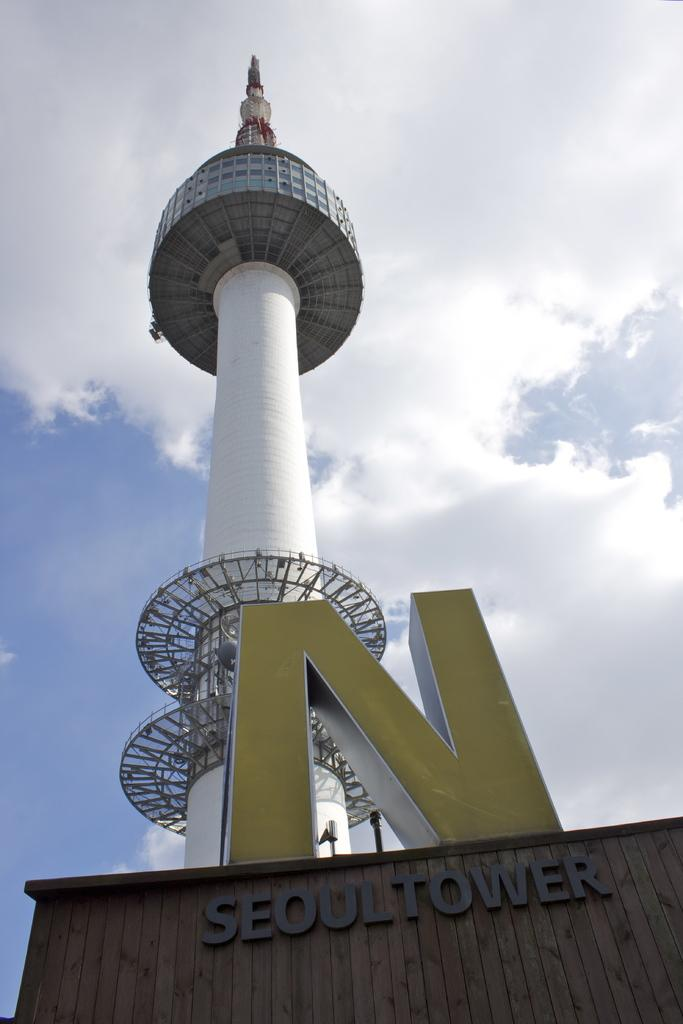What is the main structure visible in the image? There is a tower in the image. What else can be seen on a surface in the image? There is text on a wall in the image. How would you describe the sky in the image? The sky is blue and cloudy in the image. Where is the cap being stored in the image? There is no cap present in the image. Can you tell me how many times the person in the image stretches their arms? There is no person visible in the image, and therefore no stretching of arms can be observed. 